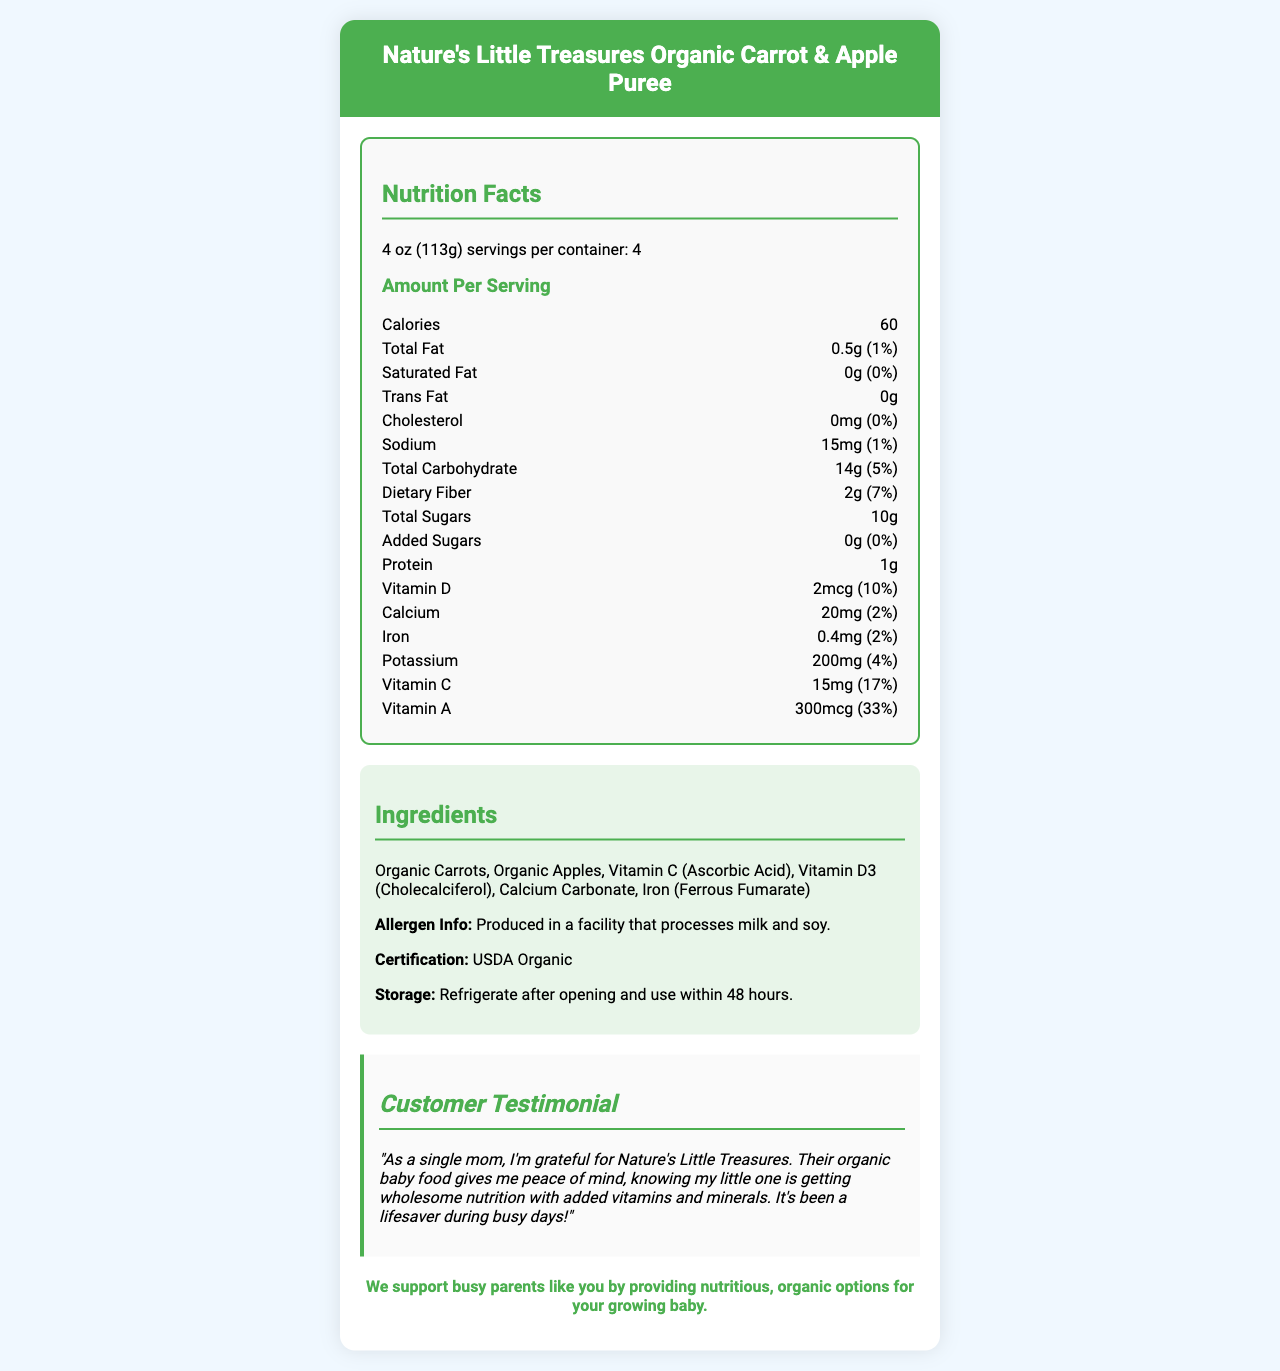what is one serving size of "Nature's Little Treasures Organic Carrot & Apple Puree"? The document states that each serving size is 4 oz (113g).
Answer: 4 oz (113g) how many servings are there in one container of this product? The document mentions that there are 4 servings per container.
Answer: 4 how many calories are in each serving of this baby food? The nutrition facts specify that there are 60 calories per serving.
Answer: 60 calories what is the daily value percentage of dietary fiber in one serving? The document lists the daily value percentage of dietary fiber as 7%.
Answer: 7% how much protein does one serving contain? The nutrition facts indicate that there is 1 gram of protein per serving.
Answer: 1g which ingredient in the product contributes to the vitamin C content? The ingredients list includes Vitamin C (Ascorbic Acid), which contributes to the vitamin C content.
Answer: Vitamin C (Ascorbic Acid) what is the allergen information for this product? The document states that allergen information specifies that it is produced in a facility that processes milk and soy.
Answer: Produced in a facility that processes milk and soy. what certification does this product have? A. Non-GMO B. USDA Organic C. Gluten-Free D. Vegan The document mentions that the certification is USDA Organic.
Answer: B. USDA Organic what mineral in this product has the highest daily value percentage per serving? A. Calcium B. Iron C. Potassium D. Vitamin A The vitamin and mineral section shows that Vitamin A has a 33% daily value, which is the highest among the listed minerals and vitamins.
Answer: D. Vitamin A what is the storage instruction after opening this product? The document specifies to refrigerate after opening and to use within 48 hours.
Answer: Refrigerate after opening and use within 48 hours. is there any trans fat in this product? The nutrition facts indicate that the amount of trans fat is 0g.
Answer: No who gave the testimonial on this product? The document includes a testimonial given by a single mom.
Answer: A single mom how much total carbohydrate is in one serving of the product? The nutrition facts label notes that there are 14 grams of total carbohydrate per serving.
Answer: 14g describe the main idea of the document. The document serves to inform customers about the detailed nutritional content and benefits of the product to ensure they are making a healthy choice for their babies.
Answer: The document provides comprehensive nutritional information for "Nature's Little Treasures Organic Carrot & Apple Puree". It highlights the serving size, number of servings per container, calories, and detailed nutrient content per serving. The product features organic ingredients with added vitamins and minerals and is certified USDA Organic. It also includes a customer testimonial, allergen information, and storage instructions. what is the primary motivator behind the brand's promise? The document explicitly states that the brand’s promise is to support busy parents like you by providing nutritious, organic options for your growing baby.
Answer: To support busy parents by providing nutritious, organic options for their growing baby. which vitamin has the highest daily value percentage per serving in this product? According to the nutrition facts, Vitamin A has a 33% daily value, which is the highest among the listed vitamins.
Answer: Vitamin A how much added sugar does one serving of this product contain? The nutrition facts label shows that there is 0g of added sugar per serving.
Answer: 0g how did you find the amount of potassium in this product? The document does not provide explicit steps or methods on how to find the amount of potassium; it simply states the value.
Answer: Not enough information what precautions should be taken for those with milk or soy allergies? The allergen information in the document notes that the product is produced in a facility that processes milk and soy, indicating a potential risk of cross-contamination.
Answer: The product is produced in a facility that processes milk and soy, so precaution should be taken due to potential cross-contamination. 